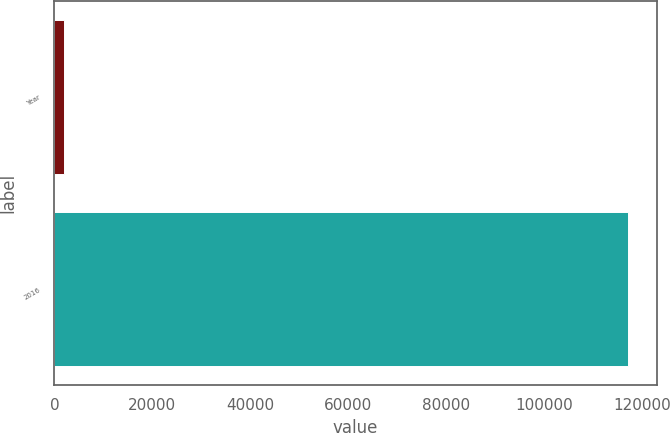Convert chart to OTSL. <chart><loc_0><loc_0><loc_500><loc_500><bar_chart><fcel>Year<fcel>2016<nl><fcel>2016<fcel>117258<nl></chart> 